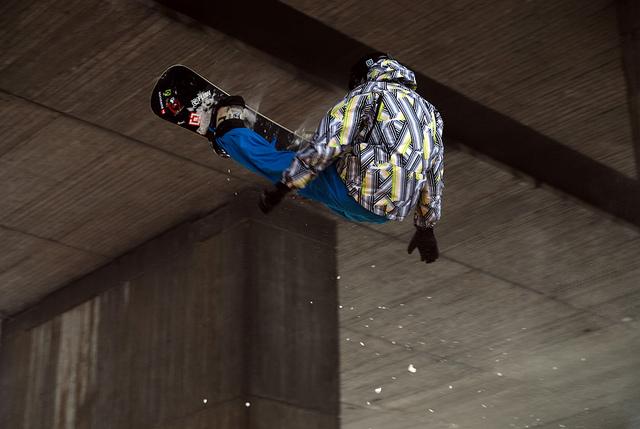What color are the pants?
Answer briefly. Blue. Is he skateboarding?
Answer briefly. No. Why is the man on the ceiling?
Write a very short answer. Doing trick. 